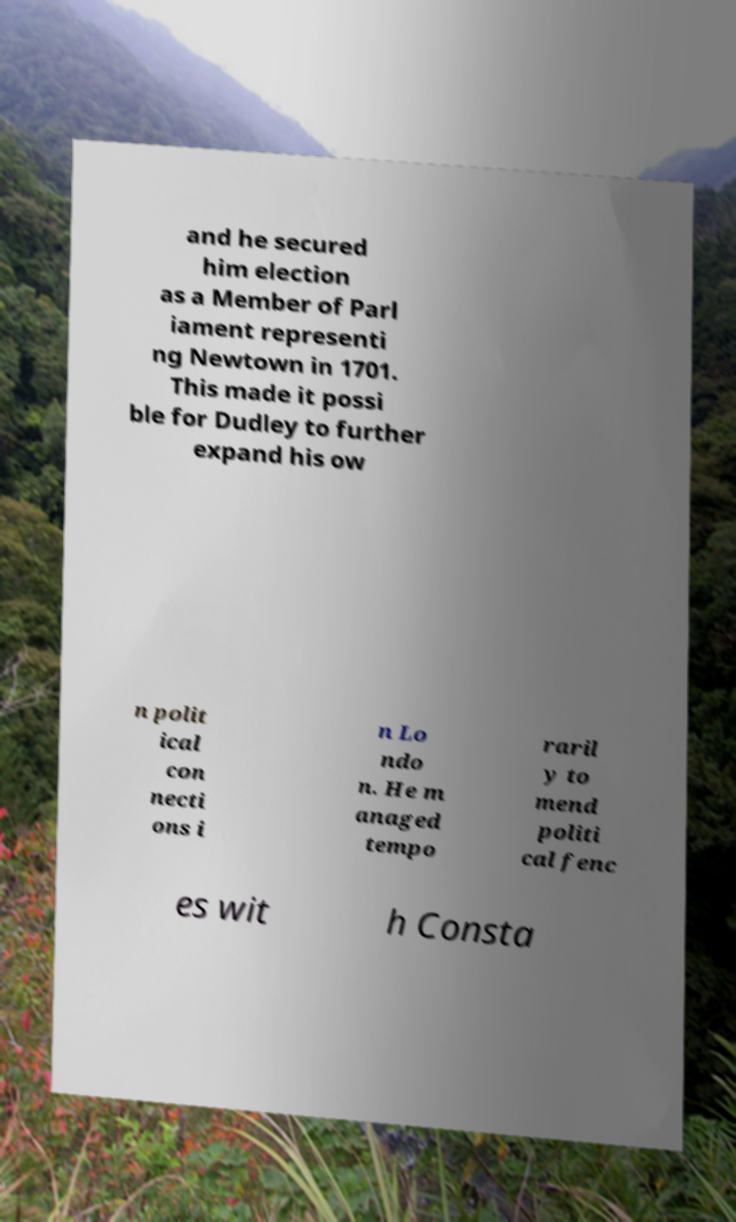Could you assist in decoding the text presented in this image and type it out clearly? and he secured him election as a Member of Parl iament representi ng Newtown in 1701. This made it possi ble for Dudley to further expand his ow n polit ical con necti ons i n Lo ndo n. He m anaged tempo raril y to mend politi cal fenc es wit h Consta 